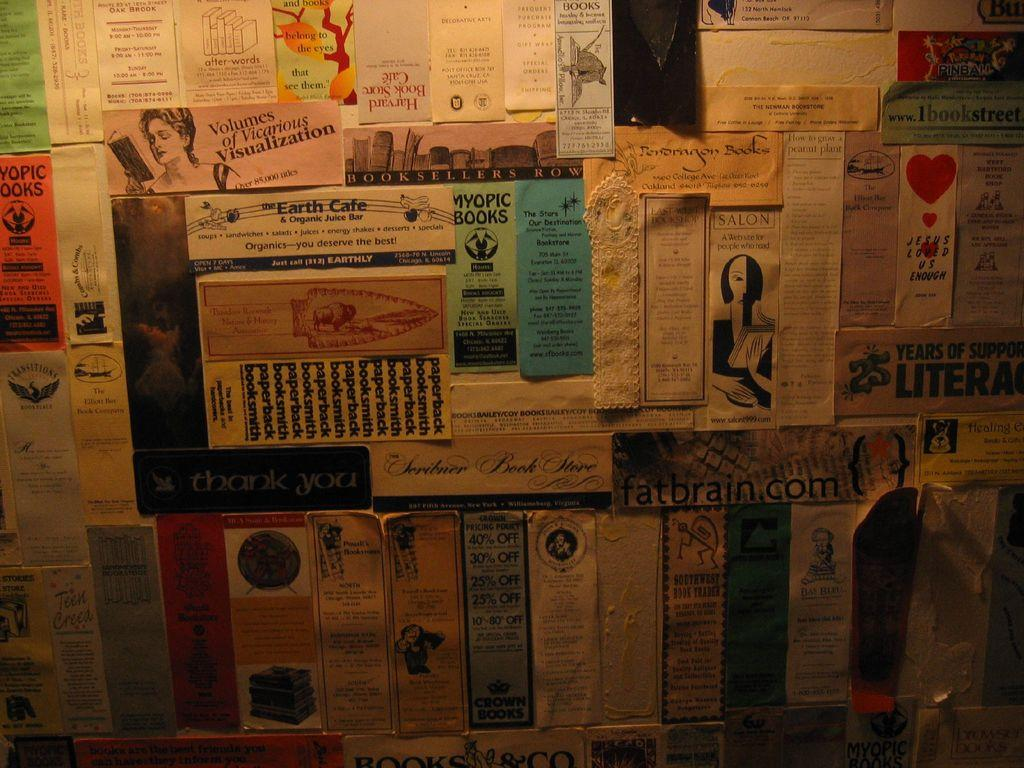<image>
Render a clear and concise summary of the photo. Wall full of many posters including one that says Myopic Books. 